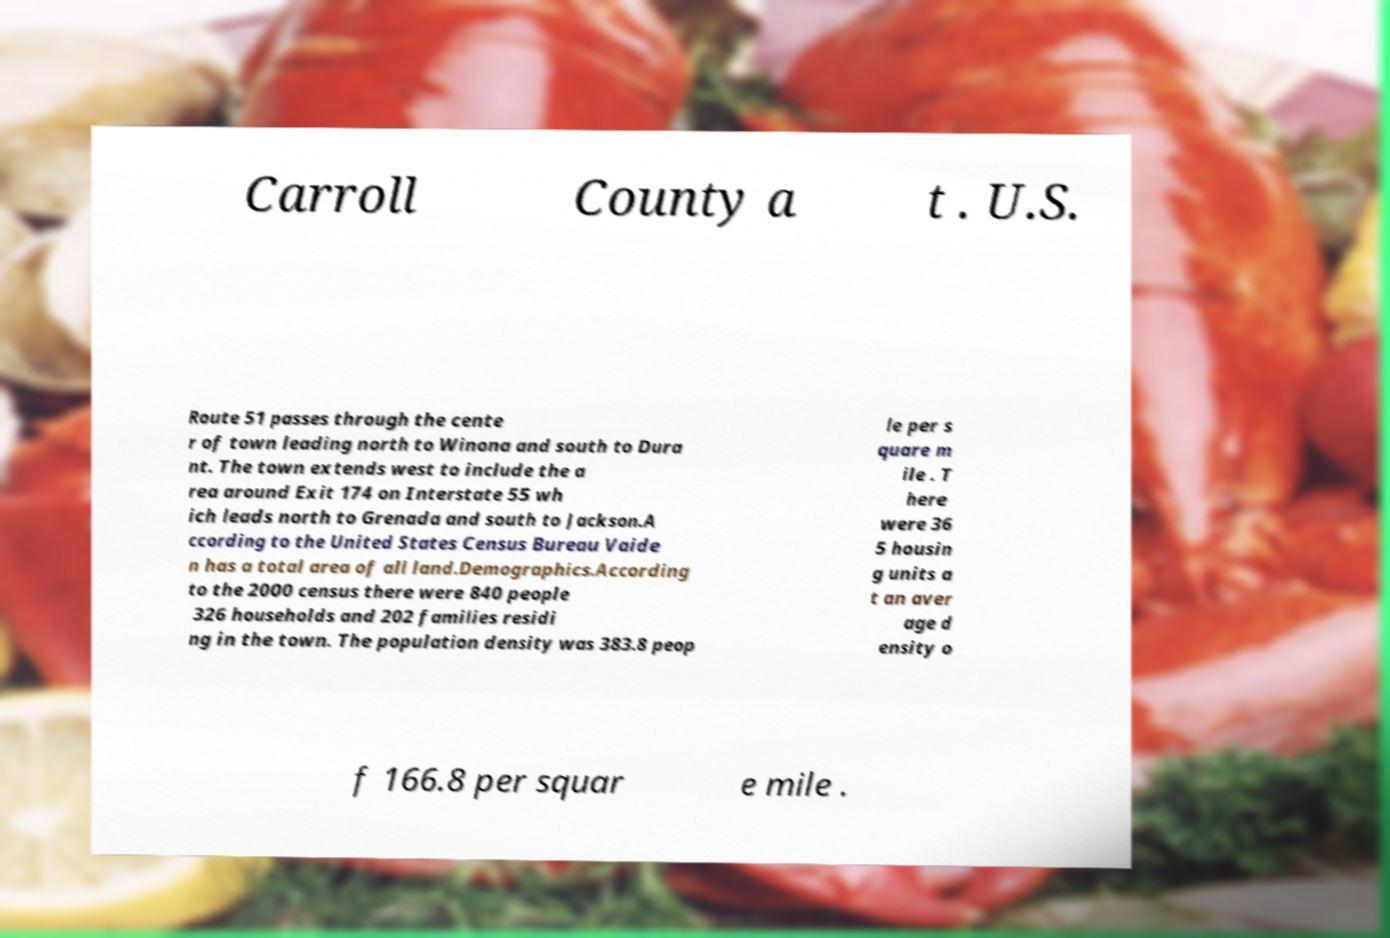Can you read and provide the text displayed in the image?This photo seems to have some interesting text. Can you extract and type it out for me? Carroll County a t . U.S. Route 51 passes through the cente r of town leading north to Winona and south to Dura nt. The town extends west to include the a rea around Exit 174 on Interstate 55 wh ich leads north to Grenada and south to Jackson.A ccording to the United States Census Bureau Vaide n has a total area of all land.Demographics.According to the 2000 census there were 840 people 326 households and 202 families residi ng in the town. The population density was 383.8 peop le per s quare m ile . T here were 36 5 housin g units a t an aver age d ensity o f 166.8 per squar e mile . 